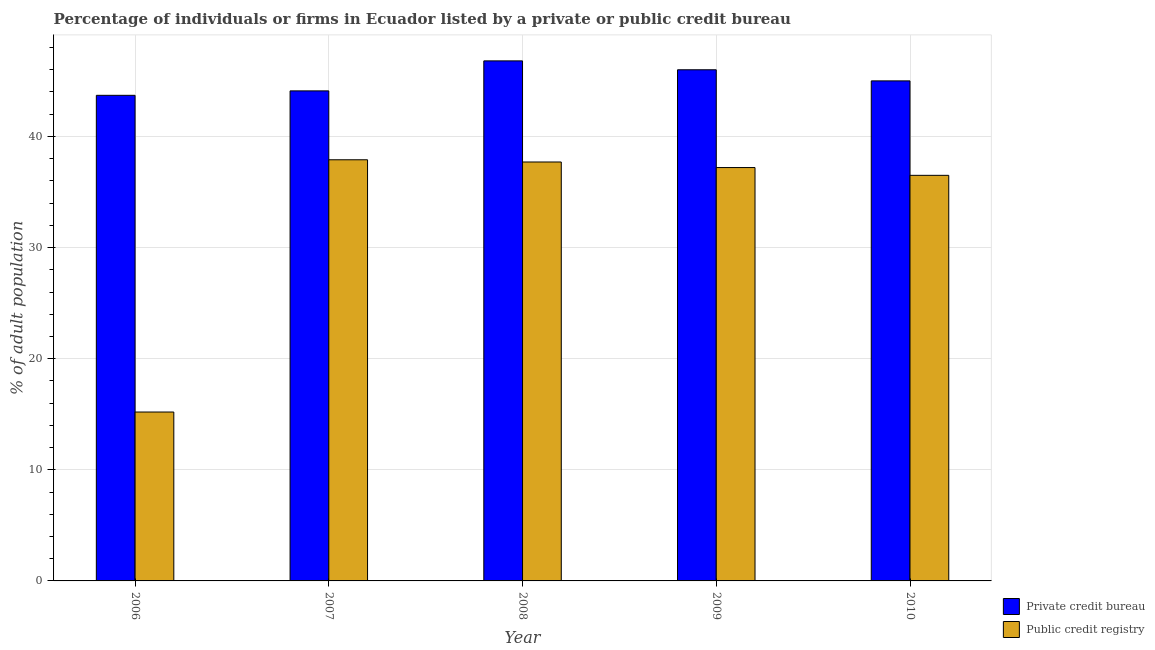How many different coloured bars are there?
Your answer should be compact. 2. In how many cases, is the number of bars for a given year not equal to the number of legend labels?
Provide a succinct answer. 0. Across all years, what is the maximum percentage of firms listed by public credit bureau?
Keep it short and to the point. 37.9. In which year was the percentage of firms listed by public credit bureau maximum?
Your answer should be compact. 2007. In which year was the percentage of firms listed by public credit bureau minimum?
Provide a succinct answer. 2006. What is the total percentage of firms listed by public credit bureau in the graph?
Your answer should be very brief. 164.5. What is the difference between the percentage of firms listed by public credit bureau in 2006 and that in 2008?
Your response must be concise. -22.5. What is the difference between the percentage of firms listed by public credit bureau in 2008 and the percentage of firms listed by private credit bureau in 2006?
Make the answer very short. 22.5. What is the average percentage of firms listed by public credit bureau per year?
Your answer should be compact. 32.9. What is the ratio of the percentage of firms listed by private credit bureau in 2009 to that in 2010?
Keep it short and to the point. 1.02. What is the difference between the highest and the second highest percentage of firms listed by public credit bureau?
Your answer should be very brief. 0.2. What is the difference between the highest and the lowest percentage of firms listed by public credit bureau?
Ensure brevity in your answer.  22.7. What does the 2nd bar from the left in 2007 represents?
Keep it short and to the point. Public credit registry. What does the 2nd bar from the right in 2010 represents?
Keep it short and to the point. Private credit bureau. What is the difference between two consecutive major ticks on the Y-axis?
Your answer should be compact. 10. Are the values on the major ticks of Y-axis written in scientific E-notation?
Your answer should be very brief. No. Does the graph contain any zero values?
Offer a very short reply. No. Does the graph contain grids?
Your answer should be very brief. Yes. How many legend labels are there?
Your response must be concise. 2. How are the legend labels stacked?
Your answer should be very brief. Vertical. What is the title of the graph?
Your response must be concise. Percentage of individuals or firms in Ecuador listed by a private or public credit bureau. Does "Taxes" appear as one of the legend labels in the graph?
Your answer should be compact. No. What is the label or title of the X-axis?
Provide a succinct answer. Year. What is the label or title of the Y-axis?
Ensure brevity in your answer.  % of adult population. What is the % of adult population in Private credit bureau in 2006?
Offer a very short reply. 43.7. What is the % of adult population in Private credit bureau in 2007?
Your answer should be very brief. 44.1. What is the % of adult population in Public credit registry in 2007?
Give a very brief answer. 37.9. What is the % of adult population of Private credit bureau in 2008?
Make the answer very short. 46.8. What is the % of adult population in Public credit registry in 2008?
Make the answer very short. 37.7. What is the % of adult population in Private credit bureau in 2009?
Ensure brevity in your answer.  46. What is the % of adult population of Public credit registry in 2009?
Give a very brief answer. 37.2. What is the % of adult population in Public credit registry in 2010?
Give a very brief answer. 36.5. Across all years, what is the maximum % of adult population of Private credit bureau?
Your response must be concise. 46.8. Across all years, what is the maximum % of adult population in Public credit registry?
Ensure brevity in your answer.  37.9. Across all years, what is the minimum % of adult population of Private credit bureau?
Make the answer very short. 43.7. Across all years, what is the minimum % of adult population in Public credit registry?
Your answer should be very brief. 15.2. What is the total % of adult population in Private credit bureau in the graph?
Make the answer very short. 225.6. What is the total % of adult population of Public credit registry in the graph?
Provide a short and direct response. 164.5. What is the difference between the % of adult population of Private credit bureau in 2006 and that in 2007?
Give a very brief answer. -0.4. What is the difference between the % of adult population of Public credit registry in 2006 and that in 2007?
Give a very brief answer. -22.7. What is the difference between the % of adult population of Public credit registry in 2006 and that in 2008?
Ensure brevity in your answer.  -22.5. What is the difference between the % of adult population of Private credit bureau in 2006 and that in 2010?
Make the answer very short. -1.3. What is the difference between the % of adult population of Public credit registry in 2006 and that in 2010?
Keep it short and to the point. -21.3. What is the difference between the % of adult population of Private credit bureau in 2007 and that in 2009?
Provide a short and direct response. -1.9. What is the difference between the % of adult population of Public credit registry in 2007 and that in 2009?
Your answer should be compact. 0.7. What is the difference between the % of adult population of Public credit registry in 2007 and that in 2010?
Your answer should be very brief. 1.4. What is the difference between the % of adult population of Private credit bureau in 2009 and that in 2010?
Offer a very short reply. 1. What is the difference between the % of adult population in Private credit bureau in 2006 and the % of adult population in Public credit registry in 2007?
Give a very brief answer. 5.8. What is the difference between the % of adult population in Private credit bureau in 2006 and the % of adult population in Public credit registry in 2009?
Ensure brevity in your answer.  6.5. What is the difference between the % of adult population of Private credit bureau in 2006 and the % of adult population of Public credit registry in 2010?
Your answer should be compact. 7.2. What is the difference between the % of adult population in Private credit bureau in 2007 and the % of adult population in Public credit registry in 2009?
Provide a short and direct response. 6.9. What is the difference between the % of adult population of Private credit bureau in 2007 and the % of adult population of Public credit registry in 2010?
Keep it short and to the point. 7.6. What is the difference between the % of adult population of Private credit bureau in 2008 and the % of adult population of Public credit registry in 2009?
Your answer should be very brief. 9.6. What is the average % of adult population in Private credit bureau per year?
Your answer should be very brief. 45.12. What is the average % of adult population of Public credit registry per year?
Provide a succinct answer. 32.9. In the year 2008, what is the difference between the % of adult population of Private credit bureau and % of adult population of Public credit registry?
Keep it short and to the point. 9.1. In the year 2009, what is the difference between the % of adult population of Private credit bureau and % of adult population of Public credit registry?
Give a very brief answer. 8.8. In the year 2010, what is the difference between the % of adult population in Private credit bureau and % of adult population in Public credit registry?
Keep it short and to the point. 8.5. What is the ratio of the % of adult population in Private credit bureau in 2006 to that in 2007?
Your answer should be very brief. 0.99. What is the ratio of the % of adult population in Public credit registry in 2006 to that in 2007?
Your answer should be compact. 0.4. What is the ratio of the % of adult population in Private credit bureau in 2006 to that in 2008?
Your answer should be compact. 0.93. What is the ratio of the % of adult population in Public credit registry in 2006 to that in 2008?
Your answer should be very brief. 0.4. What is the ratio of the % of adult population in Public credit registry in 2006 to that in 2009?
Keep it short and to the point. 0.41. What is the ratio of the % of adult population of Private credit bureau in 2006 to that in 2010?
Provide a succinct answer. 0.97. What is the ratio of the % of adult population of Public credit registry in 2006 to that in 2010?
Your answer should be very brief. 0.42. What is the ratio of the % of adult population in Private credit bureau in 2007 to that in 2008?
Make the answer very short. 0.94. What is the ratio of the % of adult population in Public credit registry in 2007 to that in 2008?
Provide a short and direct response. 1.01. What is the ratio of the % of adult population of Private credit bureau in 2007 to that in 2009?
Keep it short and to the point. 0.96. What is the ratio of the % of adult population in Public credit registry in 2007 to that in 2009?
Give a very brief answer. 1.02. What is the ratio of the % of adult population in Private credit bureau in 2007 to that in 2010?
Your response must be concise. 0.98. What is the ratio of the % of adult population of Public credit registry in 2007 to that in 2010?
Provide a succinct answer. 1.04. What is the ratio of the % of adult population of Private credit bureau in 2008 to that in 2009?
Provide a succinct answer. 1.02. What is the ratio of the % of adult population of Public credit registry in 2008 to that in 2009?
Your answer should be very brief. 1.01. What is the ratio of the % of adult population of Private credit bureau in 2008 to that in 2010?
Your answer should be compact. 1.04. What is the ratio of the % of adult population in Public credit registry in 2008 to that in 2010?
Provide a short and direct response. 1.03. What is the ratio of the % of adult population of Private credit bureau in 2009 to that in 2010?
Your response must be concise. 1.02. What is the ratio of the % of adult population of Public credit registry in 2009 to that in 2010?
Make the answer very short. 1.02. What is the difference between the highest and the second highest % of adult population in Private credit bureau?
Offer a terse response. 0.8. What is the difference between the highest and the second highest % of adult population in Public credit registry?
Your answer should be compact. 0.2. What is the difference between the highest and the lowest % of adult population of Private credit bureau?
Offer a terse response. 3.1. What is the difference between the highest and the lowest % of adult population of Public credit registry?
Make the answer very short. 22.7. 